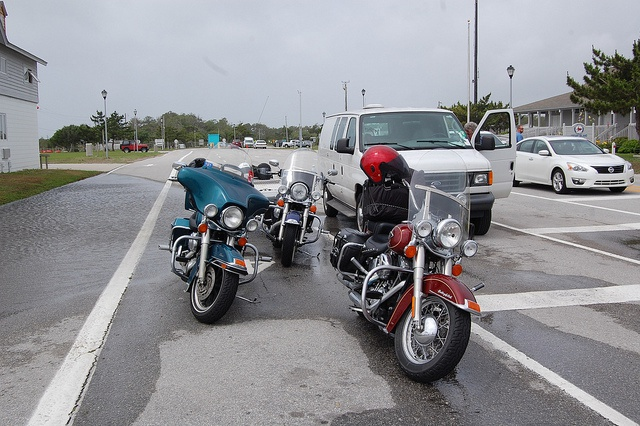Describe the objects in this image and their specific colors. I can see motorcycle in lightgray, black, gray, and darkgray tones, truck in lightgray, gray, darkgray, and black tones, car in lightgray, darkgray, gray, and black tones, motorcycle in lightgray, black, gray, darkgray, and blue tones, and motorcycle in lightgray, black, darkgray, and gray tones in this image. 